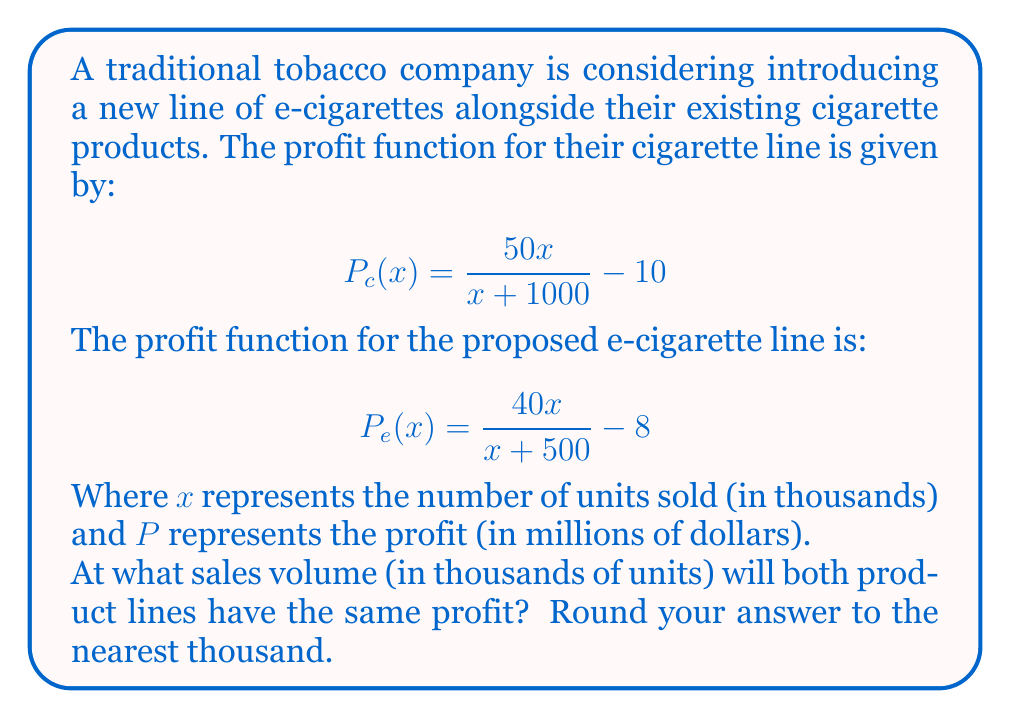Solve this math problem. To find the break-even point between the two product lines, we need to set the profit functions equal to each other and solve for x:

$$P_c(x) = P_e(x)$$

$$\frac{50x}{x + 1000} - 10 = \frac{40x}{x + 500} - 8$$

First, let's add 10 to both sides to eliminate the constant on the left:

$$\frac{50x}{x + 1000} = \frac{40x}{x + 500} + 2$$

Now, let's multiply both sides by $(x + 1000)(x + 500)$ to eliminate the denominators:

$$50x(x + 500) = 40x(x + 1000) + 2(x + 1000)(x + 500)$$

Expanding the terms:

$$50x^2 + 25000x = 40x^2 + 40000x + 2x^2 + 3000x + 1000000$$

Simplifying:

$$50x^2 + 25000x = 42x^2 + 43000x + 1000000$$

Subtracting $42x^2$ and $25000x$ from both sides:

$$8x^2 = 18000x + 1000000$$

Subtracting $18000x$ from both sides:

$$8x^2 - 18000x - 1000000 = 0$$

This is a quadratic equation. We can solve it using the quadratic formula:

$$x = \frac{-b \pm \sqrt{b^2 - 4ac}}{2a}$$

Where $a = 8$, $b = -18000$, and $c = -1000000$

$$x = \frac{18000 \pm \sqrt{(-18000)^2 - 4(8)(-1000000)}}{2(8)}$$

$$x = \frac{18000 \pm \sqrt{324000000 + 32000000}}{16}$$

$$x = \frac{18000 \pm \sqrt{356000000}}{16}$$

$$x = \frac{18000 \pm 18867.96}{16}$$

This gives us two solutions:

$$x_1 = \frac{18000 + 18867.96}{16} \approx 2304.25$$
$$x_2 = \frac{18000 - 18867.96}{16} \approx -54.25$$

Since we're dealing with sales volume, we can discard the negative solution. Rounding to the nearest thousand:

$$x \approx 2304 \text{ thousand} \approx 2304000 \text{ units}$$
Answer: 2,304,000 units 